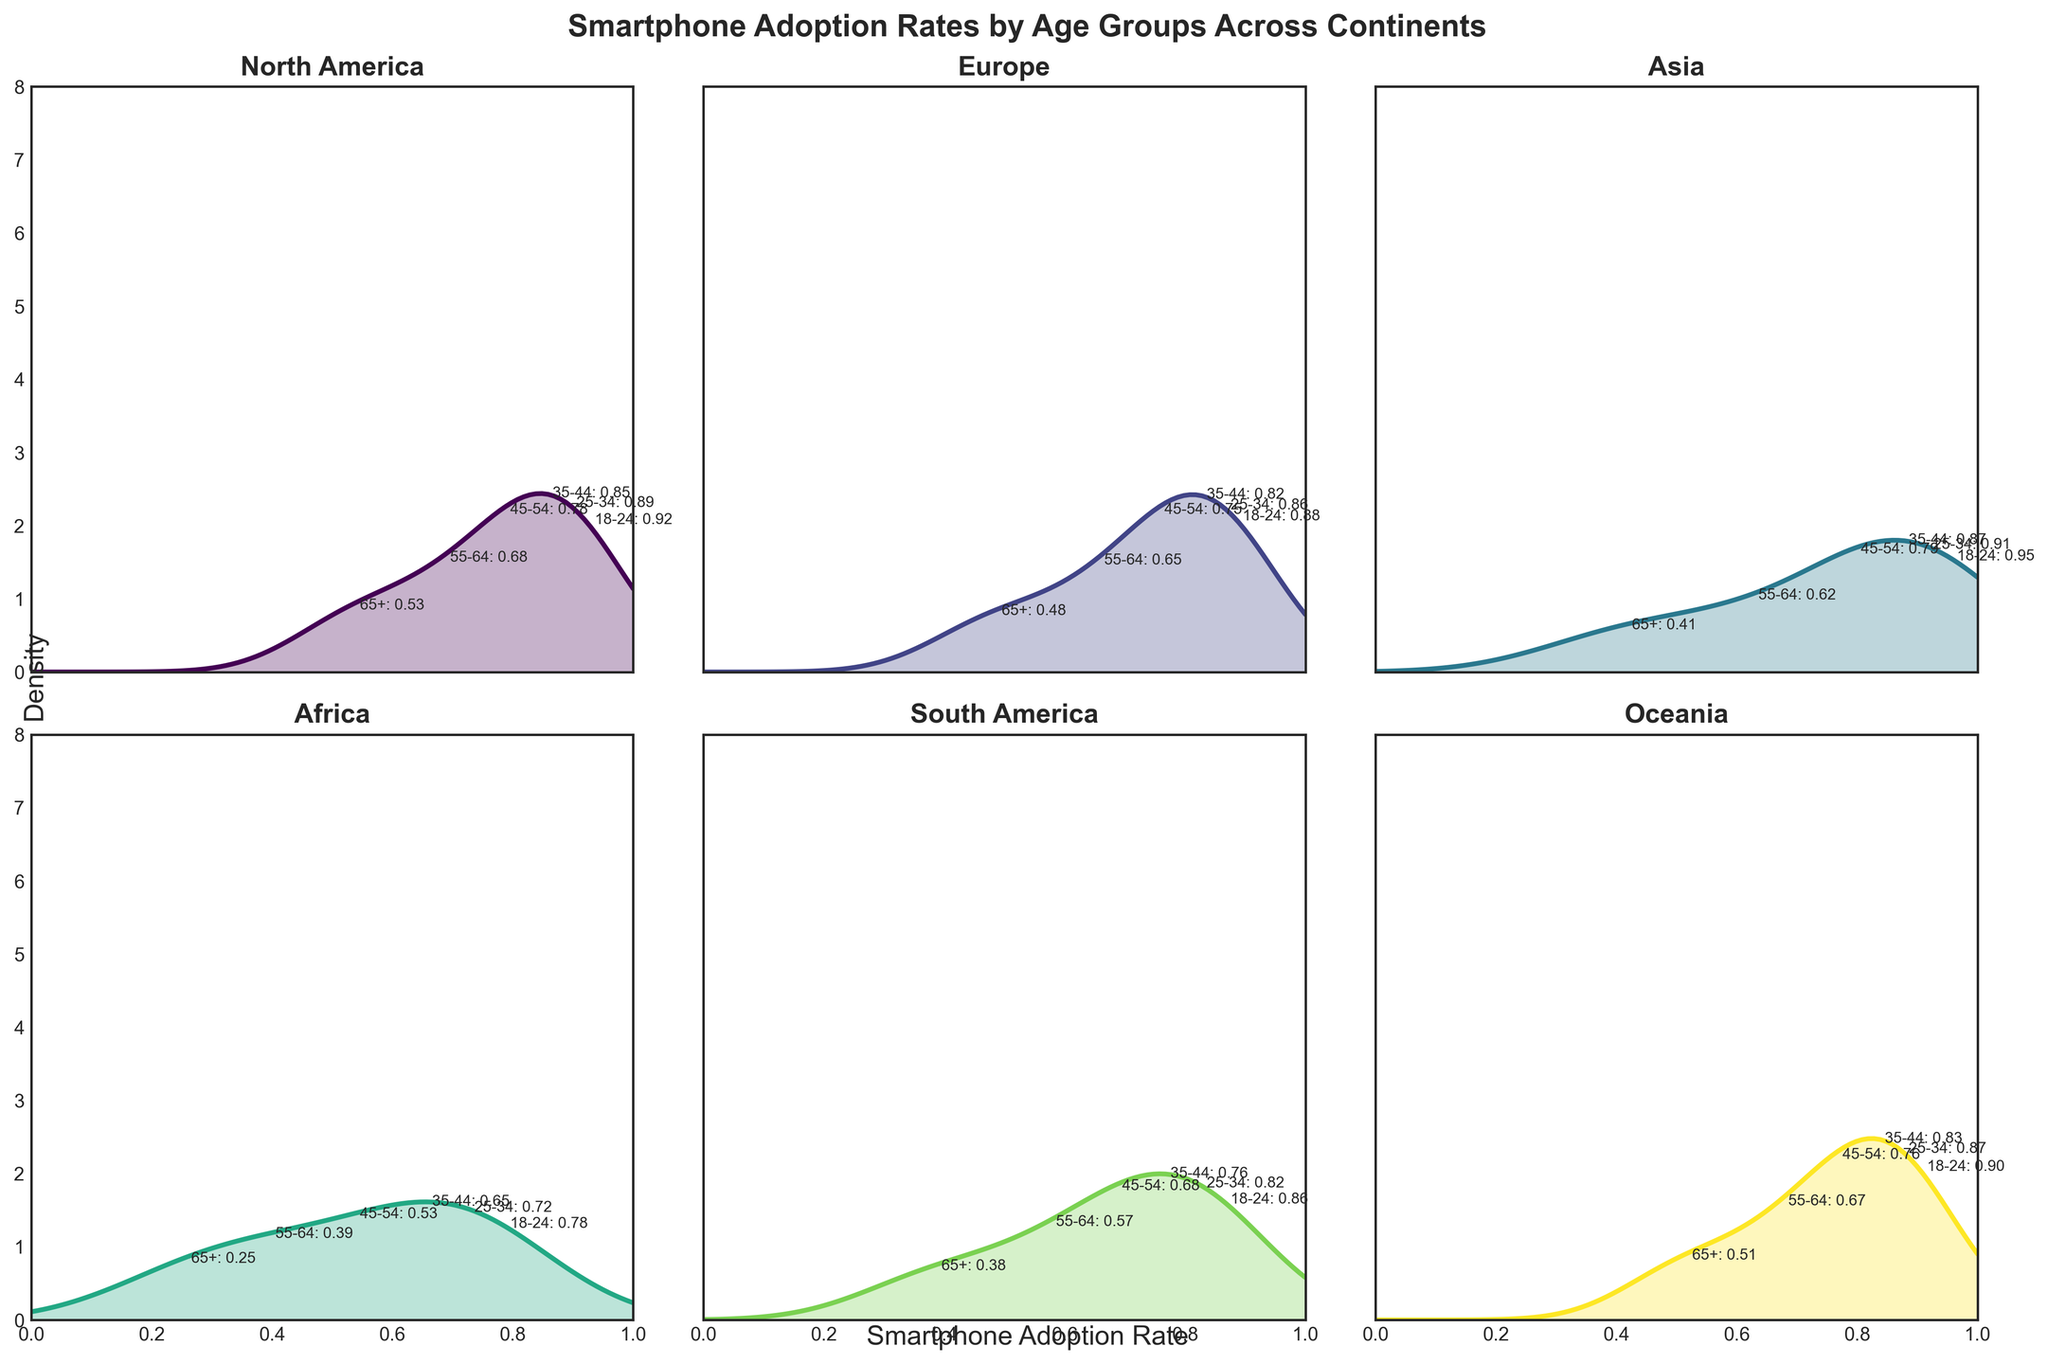What is the title of the figure? The title can be seen at the top of the figure. It is bold and states the main topic of the chart. The title reads "Smartphone Adoption Rates by Age Groups Across Continents"
Answer: Smartphone Adoption Rates by Age Groups Across Continents Which continent has the highest peak density for smartphone adoption rates? The peak density can be determined by observing which subplot has the highest peak along the density (y) axis. The subplot for North America has the highest peak.
Answer: North America In which continent is the density peak for the 18-24 age group highest? We look at the density annotations for the 18-24 age group in each plot. Asia has the highest density peak for this age group.
Answer: Asia Compare the smartphone adoption rates for the 25-34 and 35-44 age groups in Europe. Which group has a higher rate? We look at the plots for Europe and check the adoption rates annotated for 25-34 and 35-44 age groups. The 25-34 group has a higher rate (0.86) compared to the 35-44 group (0.82).
Answer: 25-34 How does the adoption rate for the 65+ age group in Africa compare to the same age group in Europe? We check the adoption rates for the 65+ age group in both Africa and Europe. Africa has an adoption rate of 0.25, while Europe has an adoption rate of 0.48, so Europe has a higher rate.
Answer: Europe (higher) What is the trend in smartphone adoption rates as age increases in South America? We examine the annotations for South America which indicate adoption rates of 0.86 (18-24), 0.82 (25-34), 0.76 (35-44), 0.68 (45-54), 0.57 (55-64), and 0.38 (65+). The trend shows a decrease in adoption rates as age increases.
Answer: Decreasing Which continent shows the most significant drop in adoption rate from 18-24 to 65+ age group? To determine this, we calculate the drop in adoption rates for each continent. Africa shows the most significant drop from 0.78 (18-24) to 0.25 (65+), which is a drop of 0.53.
Answer: Africa What is the maximum adoption rate for Oceania? The maximum adoption rate appears as the highest annotation in the Oceania subplot. The rate for the 18-24 age group is 0.90, which is the highest.
Answer: 0.90 Which continent has the smallest variation in adoption rates among age groups? We check for the smallest range between the highest and lowest adoption rates. Oceania shows the smallest variation with rates ranging from 0.90 (18-24) to 0.51 (65+), giving a variation of 0.39.
Answer: Oceania 